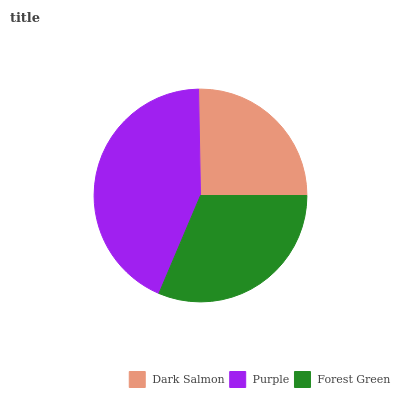Is Dark Salmon the minimum?
Answer yes or no. Yes. Is Purple the maximum?
Answer yes or no. Yes. Is Forest Green the minimum?
Answer yes or no. No. Is Forest Green the maximum?
Answer yes or no. No. Is Purple greater than Forest Green?
Answer yes or no. Yes. Is Forest Green less than Purple?
Answer yes or no. Yes. Is Forest Green greater than Purple?
Answer yes or no. No. Is Purple less than Forest Green?
Answer yes or no. No. Is Forest Green the high median?
Answer yes or no. Yes. Is Forest Green the low median?
Answer yes or no. Yes. Is Dark Salmon the high median?
Answer yes or no. No. Is Dark Salmon the low median?
Answer yes or no. No. 